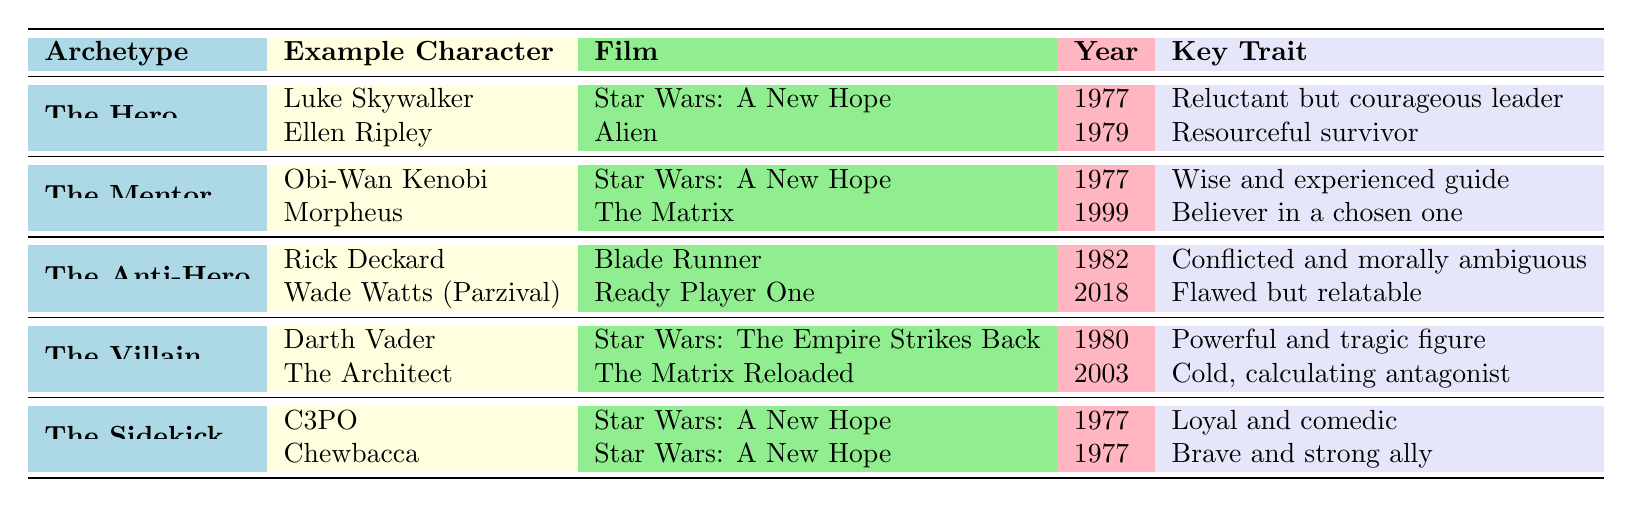What key trait is associated with Luke Skywalker? Luke Skywalker is listed under the archetype "The Hero" in the table, and his key trait is explicitly mentioned as "Reluctant but courageous leader."
Answer: Reluctant but courageous leader How many example characters are listed for "The Anti-Hero" archetype? There are two characters provided for "The Anti-Hero" archetype: Rick Deckard and Wade Watts (Parzival), as identified in their respective rows.
Answer: 2 Is Morpheus from "The Matrix" classified as a villain? The table categorizes Morpheus as part of "The Mentor" archetype and not as a villain, confirming that he does not fit the villain classification.
Answer: No Which character has the key trait of being a "cold, calculating antagonist"? The character with the key trait "Cold, calculating antagonist" listed in the table is "The Architect," which belongs to the "The Villain" archetype.
Answer: The Architect What is the common role shared by characters in "The Sidekick" archetype? The common roles for "The Sidekick" archetype are listed in the table and include "Provides humor" and "Supports the hero," showing consistent characteristics among sidekicks.
Answer: Provides humor, Supports the hero Which film features both Luke Skywalker and Obi-Wan Kenobi? The table indicates that "Star Wars: A New Hope" is the film featuring both characters, categorized under their respective archetypes.
Answer: Star Wars: A New Hope Which archetype do both Ellen Ripley and Darth Vader belong to, and what are their key traits? Ellen Ripley belongs to "The Hero" archetype with the key trait "Resourceful survivor," while Darth Vader is categorized as "The Villain" with the key trait "Powerful and tragic figure," indicating they belong to different archetypes.
Answer: Different archetypes Count the total number of films mentioned in the table. Five characters across different archetypes each belong to distinct films. Counting them gives us a total of five different films: "Star Wars: A New Hope," "Alien," "Blade Runner," "The Matrix," and "Ready Player One."
Answer: 5 